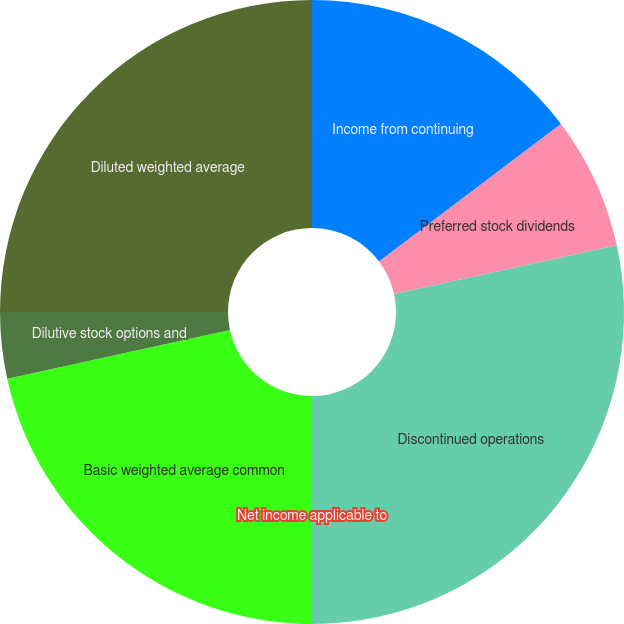<chart> <loc_0><loc_0><loc_500><loc_500><pie_chart><fcel>Income from continuing<fcel>Preferred stock dividends<fcel>Discontinued operations<fcel>Net income applicable to<fcel>Basic weighted average common<fcel>Dilutive stock options and<fcel>Diluted weighted average<nl><fcel>14.71%<fcel>6.86%<fcel>28.43%<fcel>0.0%<fcel>21.57%<fcel>3.43%<fcel>25.0%<nl></chart> 